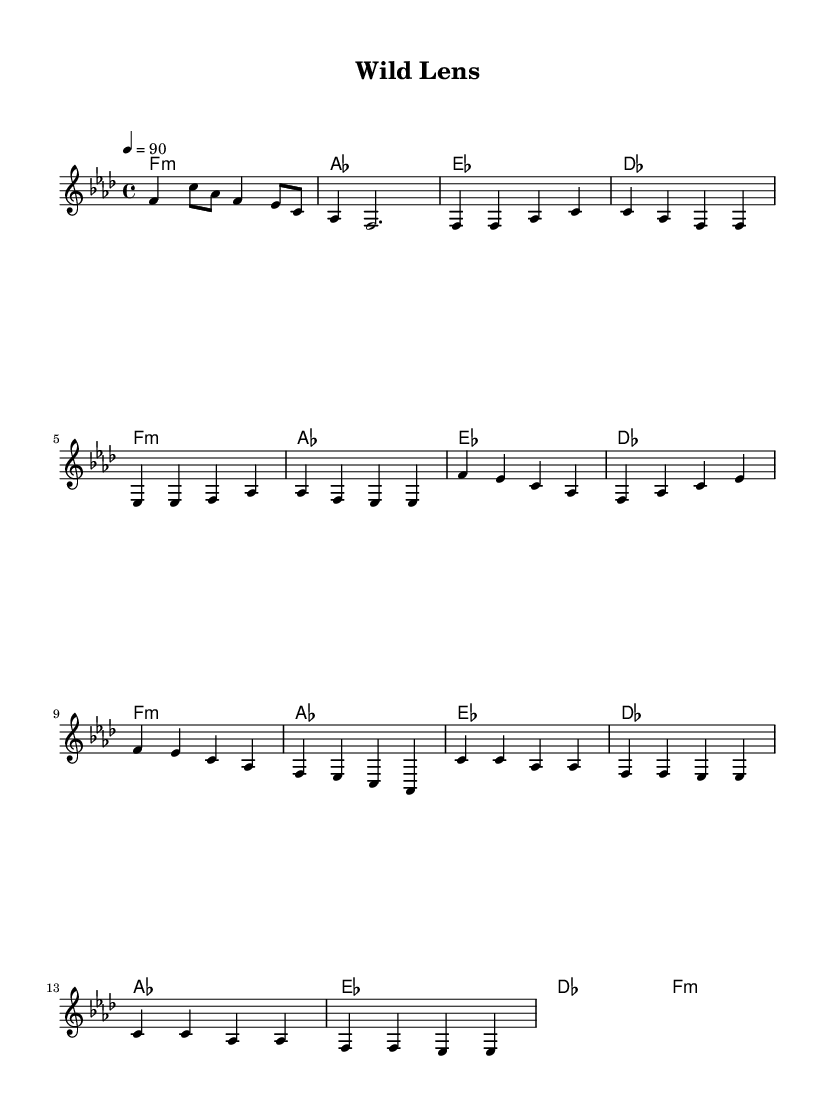What is the key signature of this music? The key signature is indicated by the number of flats or sharps before the beginning of the staff. In this case, there are 6 flats, meaning the key signature is F minor.
Answer: F minor What is the time signature of this music? The time signature is shown at the beginning of the staff and indicates how many beats are in a measure. Here, it is 4/4, meaning there are 4 beats per measure.
Answer: 4/4 What is the tempo indication for this music? The tempo marking is typically found in tempo markings located at the beginning of the music. In this case, it shows a quarter note equals 90 beats per minute.
Answer: 90 How many measures are in the chorus section? The chorus is identified by the repeated lyrics or section from the score. By counting the measures indicated in the 'Chorus' section of the music, there are 4 measures.
Answer: 4 Which section consists of the melody line that repeats notes frequently? The description of repeating notes points to the Chorus part, where the melody often returns to similar notes to create a memorable hook.
Answer: Chorus What is the relationship between the first chord and the tempo in this piece? The first chord in the piece is a minor chord (f:m), which sets a certain mood that is played at a steady tempo of 90 beats per minute, establishing a deliberate and laid-back feel for the rap style.
Answer: Minor How many unique chords are used in the harmonies section? By looking at the chord progression section, we observe four unique chords: f, as, es, and des. Counting them reveals that there are 4 unique chord types used throughout the piece.
Answer: 4 